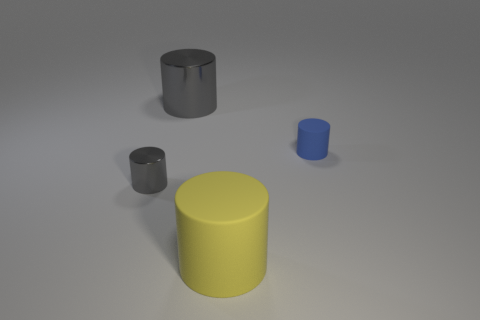What material is the cylinder that is both in front of the tiny rubber thing and behind the large yellow thing?
Keep it short and to the point. Metal. How many things are either gray things that are left of the big shiny cylinder or yellow cylinders?
Provide a short and direct response. 2. Is the color of the small matte cylinder the same as the big metal thing?
Offer a very short reply. No. Are there any purple rubber cylinders that have the same size as the yellow object?
Ensure brevity in your answer.  No. How many objects are both in front of the blue object and on the right side of the small gray cylinder?
Ensure brevity in your answer.  1. There is a big yellow rubber cylinder; what number of yellow matte cylinders are to the right of it?
Your response must be concise. 0. Are there any gray objects of the same shape as the large yellow thing?
Make the answer very short. Yes. Is the shape of the large yellow matte thing the same as the gray thing to the left of the big metal cylinder?
Your answer should be very brief. Yes. How many cubes are small blue matte things or gray things?
Ensure brevity in your answer.  0. There is a big object that is behind the small shiny thing; what is its shape?
Keep it short and to the point. Cylinder. 